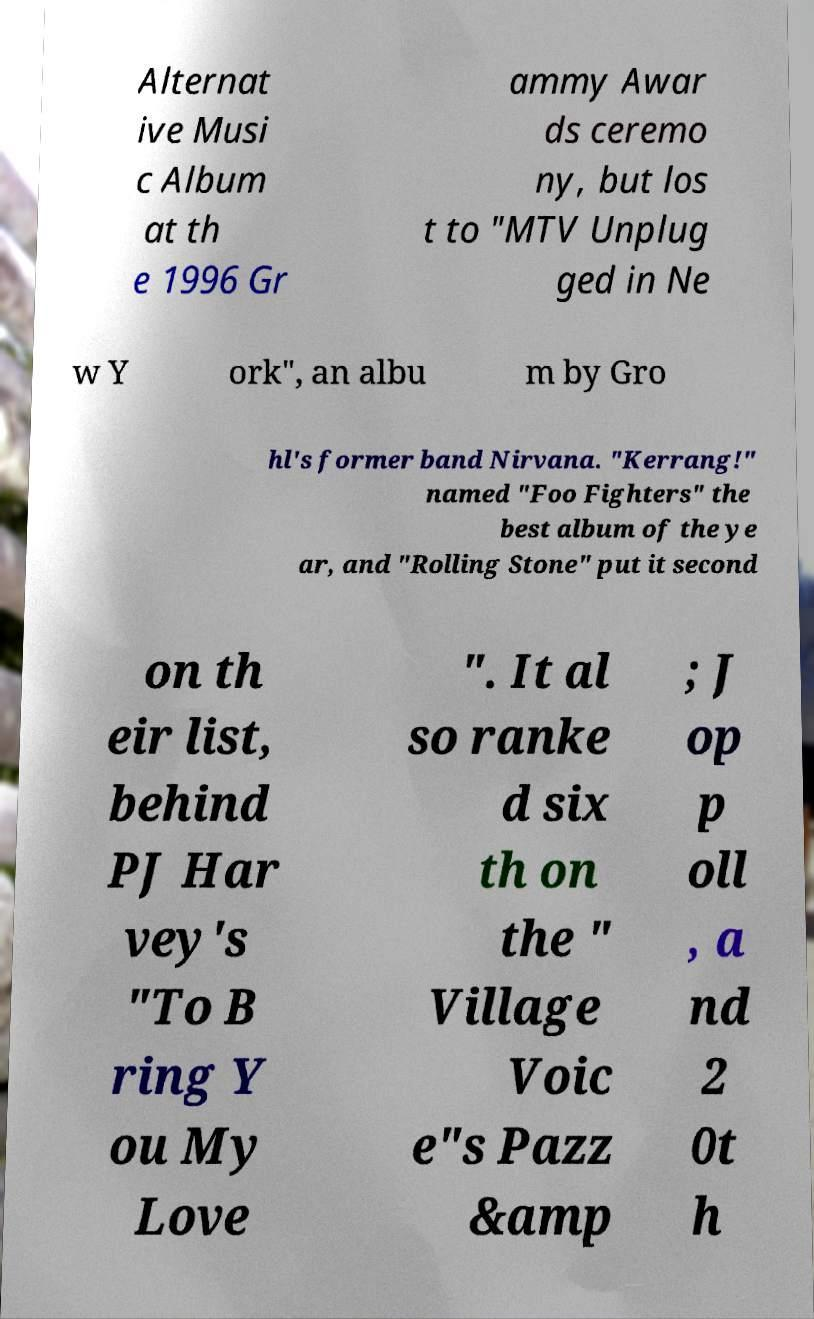Can you accurately transcribe the text from the provided image for me? Alternat ive Musi c Album at th e 1996 Gr ammy Awar ds ceremo ny, but los t to "MTV Unplug ged in Ne w Y ork", an albu m by Gro hl's former band Nirvana. "Kerrang!" named "Foo Fighters" the best album of the ye ar, and "Rolling Stone" put it second on th eir list, behind PJ Har vey's "To B ring Y ou My Love ". It al so ranke d six th on the " Village Voic e"s Pazz &amp ; J op p oll , a nd 2 0t h 